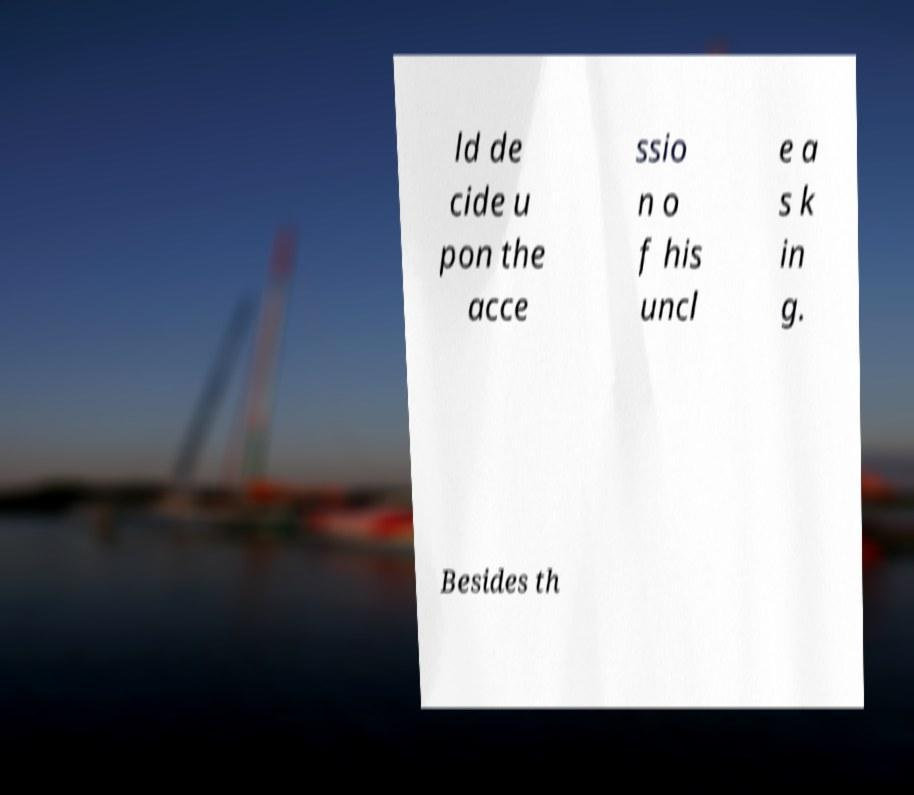Could you extract and type out the text from this image? ld de cide u pon the acce ssio n o f his uncl e a s k in g. Besides th 